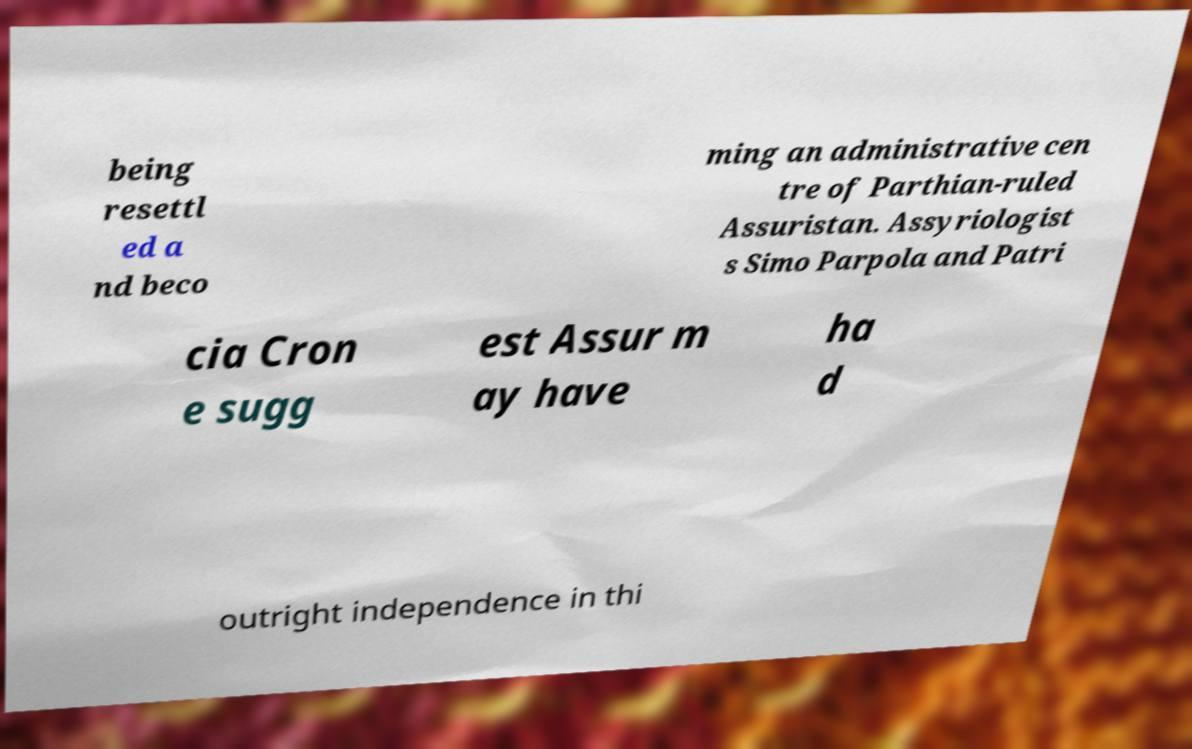There's text embedded in this image that I need extracted. Can you transcribe it verbatim? being resettl ed a nd beco ming an administrative cen tre of Parthian-ruled Assuristan. Assyriologist s Simo Parpola and Patri cia Cron e sugg est Assur m ay have ha d outright independence in thi 